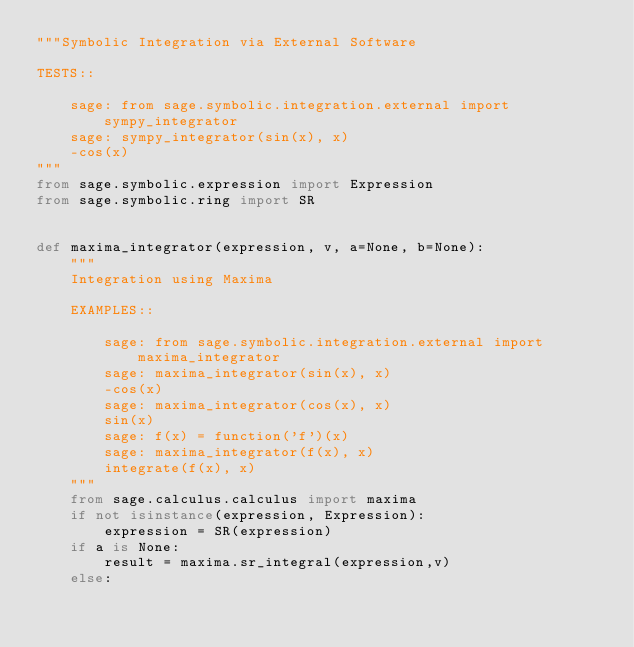Convert code to text. <code><loc_0><loc_0><loc_500><loc_500><_Python_>"""Symbolic Integration via External Software

TESTS::

    sage: from sage.symbolic.integration.external import sympy_integrator
    sage: sympy_integrator(sin(x), x)
    -cos(x)
"""
from sage.symbolic.expression import Expression
from sage.symbolic.ring import SR


def maxima_integrator(expression, v, a=None, b=None):
    """
    Integration using Maxima

    EXAMPLES::

        sage: from sage.symbolic.integration.external import maxima_integrator
        sage: maxima_integrator(sin(x), x)
        -cos(x)
        sage: maxima_integrator(cos(x), x)
        sin(x)
        sage: f(x) = function('f')(x)
        sage: maxima_integrator(f(x), x)
        integrate(f(x), x)
    """
    from sage.calculus.calculus import maxima
    if not isinstance(expression, Expression):
        expression = SR(expression)
    if a is None:
        result = maxima.sr_integral(expression,v)
    else:</code> 